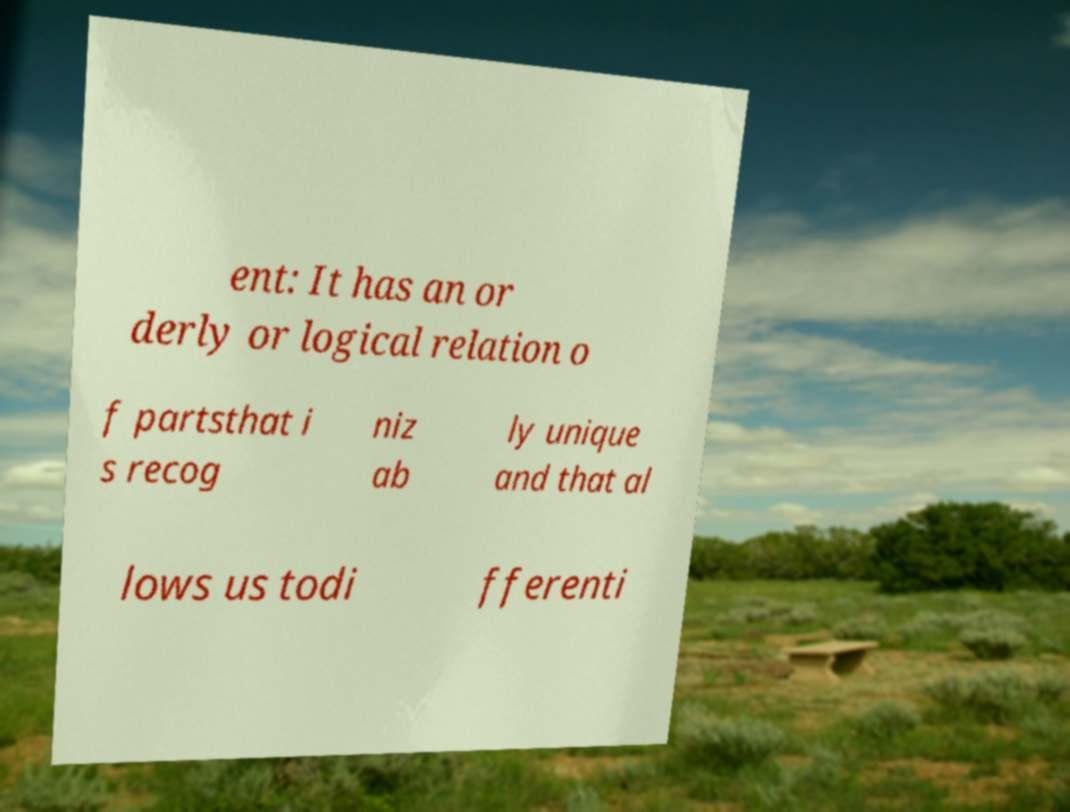Can you accurately transcribe the text from the provided image for me? ent: It has an or derly or logical relation o f partsthat i s recog niz ab ly unique and that al lows us todi fferenti 